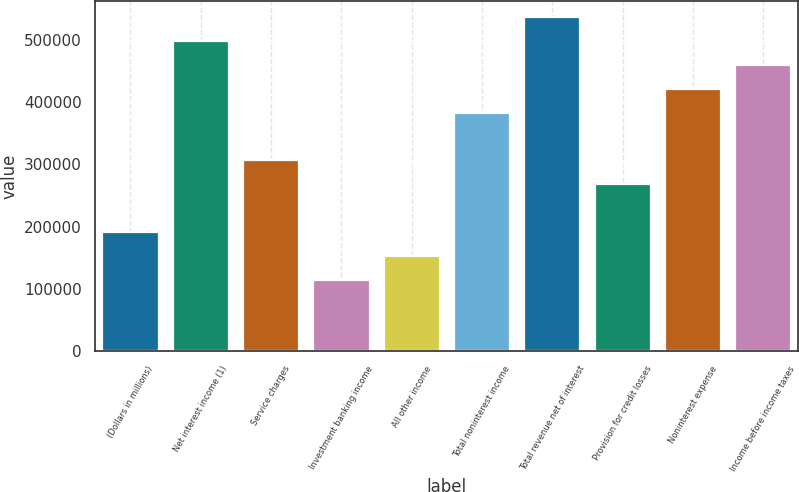<chart> <loc_0><loc_0><loc_500><loc_500><bar_chart><fcel>(Dollars in millions)<fcel>Net interest income (1)<fcel>Service charges<fcel>Investment banking income<fcel>All other income<fcel>Total noninterest income<fcel>Total revenue net of interest<fcel>Provision for credit losses<fcel>Noninterest expense<fcel>Income before income taxes<nl><fcel>191397<fcel>497626<fcel>306233<fcel>114839<fcel>153118<fcel>382790<fcel>535905<fcel>267954<fcel>421069<fcel>459347<nl></chart> 